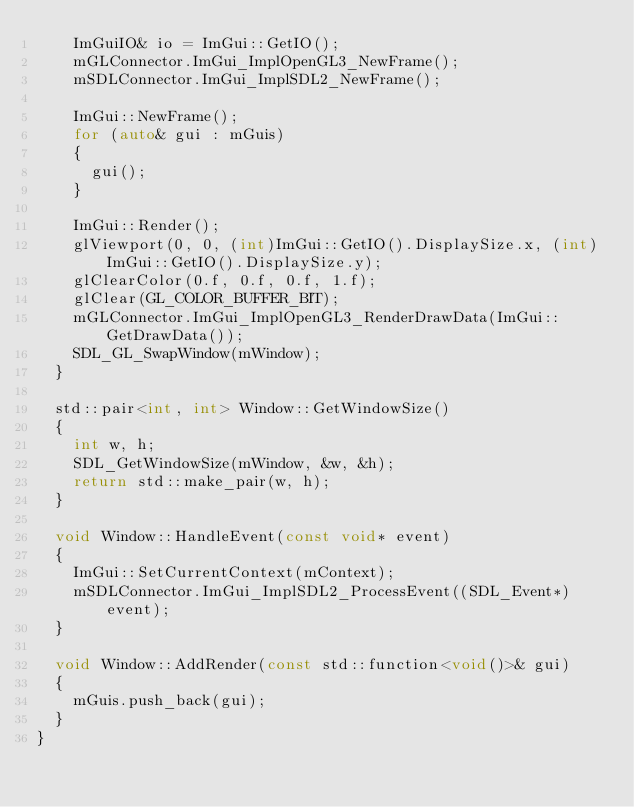<code> <loc_0><loc_0><loc_500><loc_500><_C++_>		ImGuiIO& io = ImGui::GetIO();
		mGLConnector.ImGui_ImplOpenGL3_NewFrame();
		mSDLConnector.ImGui_ImplSDL2_NewFrame();

		ImGui::NewFrame();
		for (auto& gui : mGuis)
		{
			gui();
		}

		ImGui::Render();
		glViewport(0, 0, (int)ImGui::GetIO().DisplaySize.x, (int)ImGui::GetIO().DisplaySize.y);
		glClearColor(0.f, 0.f, 0.f, 1.f);
		glClear(GL_COLOR_BUFFER_BIT);
		mGLConnector.ImGui_ImplOpenGL3_RenderDrawData(ImGui::GetDrawData());
		SDL_GL_SwapWindow(mWindow);
	}

	std::pair<int, int> Window::GetWindowSize()
	{
		int w, h;
		SDL_GetWindowSize(mWindow, &w, &h);
		return std::make_pair(w, h);
	}

	void Window::HandleEvent(const void* event)
	{
		ImGui::SetCurrentContext(mContext);
		mSDLConnector.ImGui_ImplSDL2_ProcessEvent((SDL_Event*)event);
	}

	void Window::AddRender(const std::function<void()>& gui)
	{
		mGuis.push_back(gui);
	}
}
</code> 